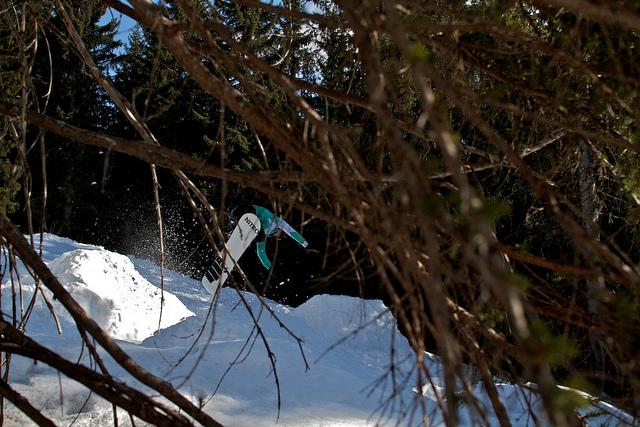How many branches can you see on the tree?
Answer briefly. 10. Did he fall?
Short answer required. Yes. Does this area appear dry or wet?
Be succinct. Wet. Are the leaves green?
Short answer required. Yes. Is it a winter day?
Short answer required. Yes. Is it daytime?
Answer briefly. Yes. What color are the leaves?
Short answer required. Green. 